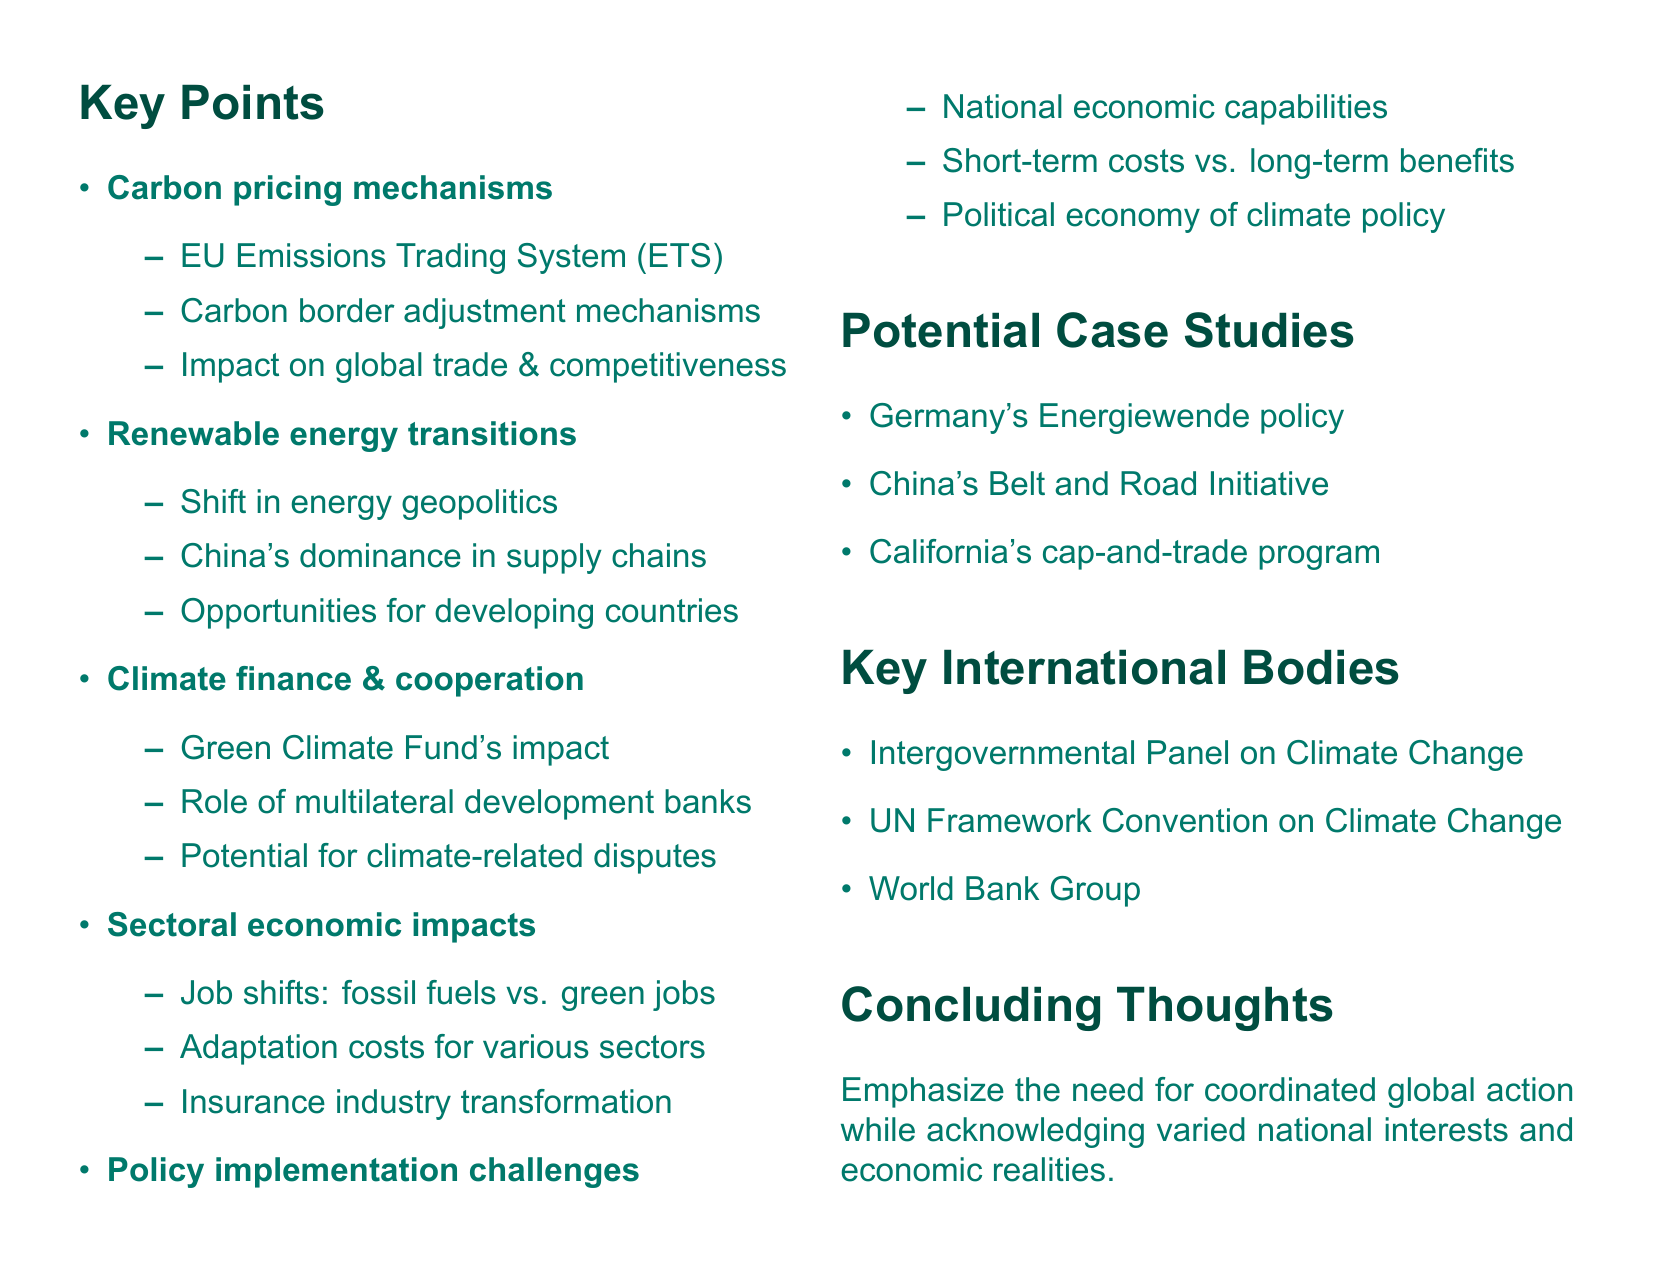What is the title of the document? The title is clearly stated at the beginning of the document, which is focused on the economic consequences of climate change policies.
Answer: Economic Consequences of Climate Change Policies: A Geopolitical Perspective What international body focuses on climate change? The document lists several key international bodies, one of which is recognized for its focus on climate change issues.
Answer: Intergovernmental Panel on Climate Change What mechanism is mentioned for carbon pricing? The document discusses specific carbon pricing mechanisms that have a significant impact on various economies.
Answer: EU Emissions Trading System Which country is dominant in renewable technology supply chains? The document highlights a specific country that plays a major role in renewable technology, indicating its influence in global energy transitions.
Answer: China What is one potential case study mentioned in the document? The document includes examples of specific policies or initiatives that can serve as case studies for analyzing climate change policies.
Answer: Germany's Energiewende policy What does the Green Climate Fund aim to impact? The document specifies the objective relating to economic improvements for a certain group of nations.
Answer: Developing economies What challenge is noted in policy implementation? The document outlines challenges faced by countries in terms of climate change policy implementation, particularly regarding economic differences.
Answer: National economic capabilities What is a concern related to climate finance? The document discusses potential issues that can arise from international climate financing efforts, particularly regarding trade.
Answer: Climate-related trade disputes What is emphasized in the concluding thoughts? The document's final section addresses the overall need for a specific type of action regarding climate change policies.
Answer: Coordinated global action 